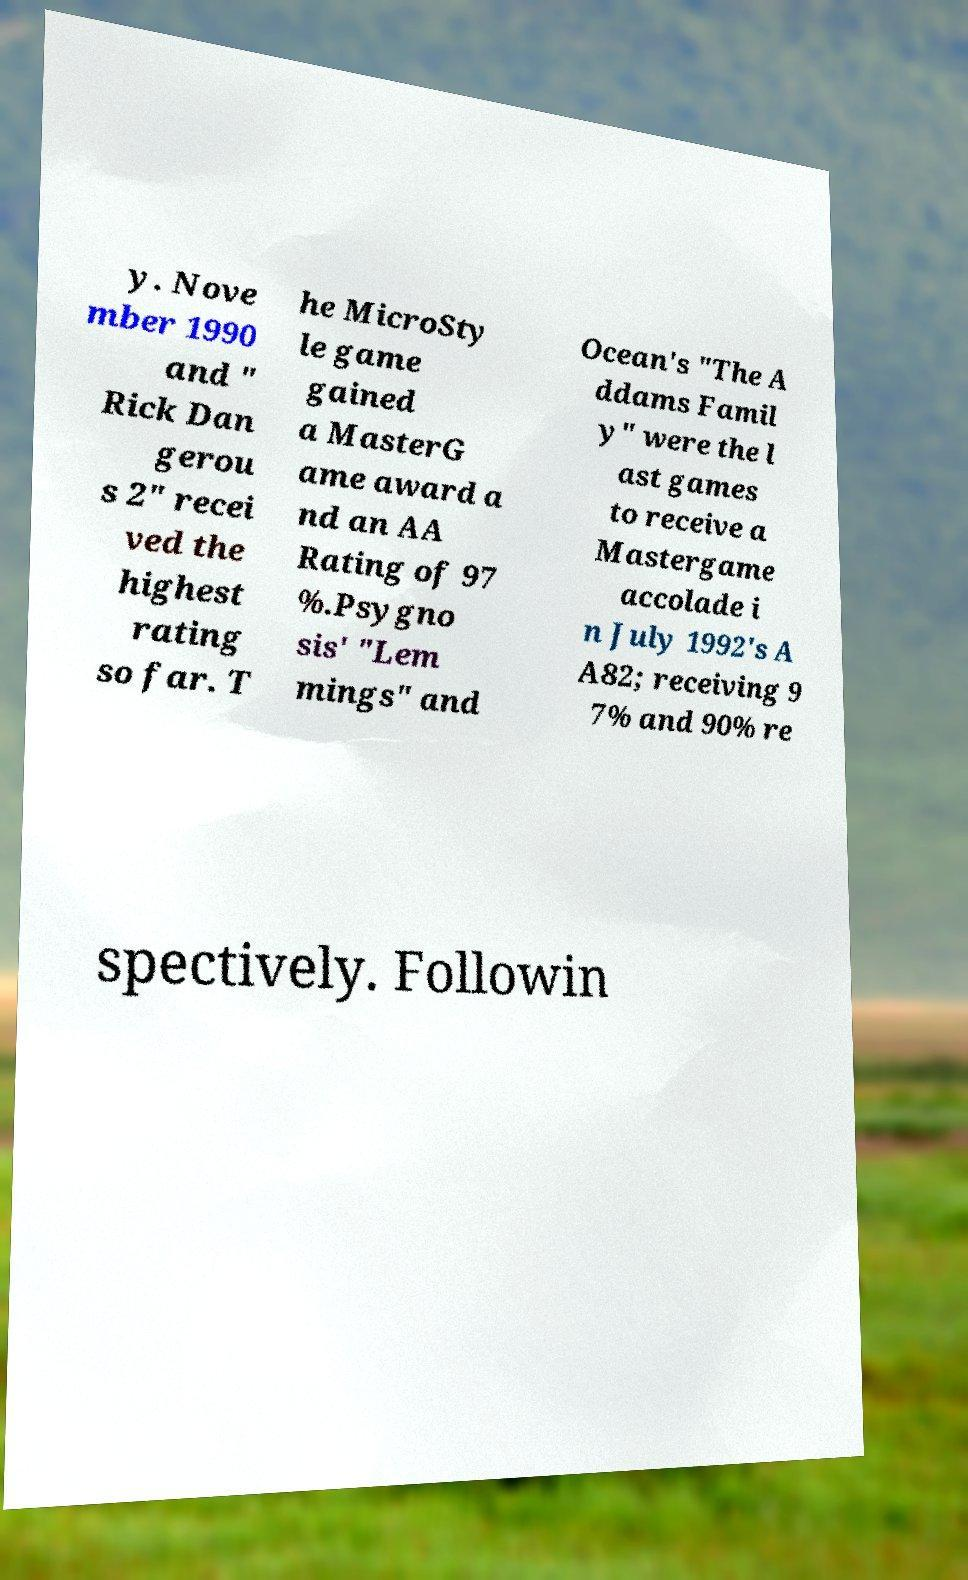I need the written content from this picture converted into text. Can you do that? y. Nove mber 1990 and " Rick Dan gerou s 2" recei ved the highest rating so far. T he MicroSty le game gained a MasterG ame award a nd an AA Rating of 97 %.Psygno sis' "Lem mings" and Ocean's "The A ddams Famil y" were the l ast games to receive a Mastergame accolade i n July 1992's A A82; receiving 9 7% and 90% re spectively. Followin 